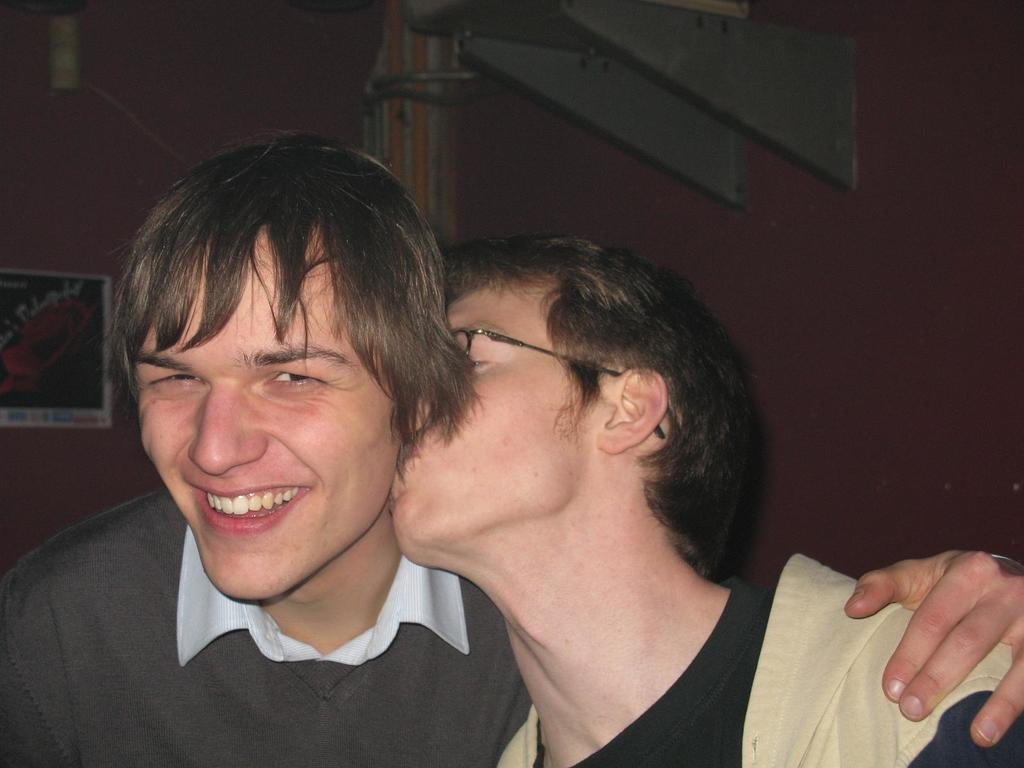How many people are in the image? There are two men in the image. What is one of the men doing in the image? One man is smiling. What action is the other man performing in the image? The other man is kissing the first man on the neck. What can be seen on the wall in the image? There is a post on the wall. What type of thread is being used by the person in the image? There is no person using thread in the image; it features two men interacting with each other. Can you describe the swimming technique of the person in the image? There is no person swimming in the image; it features two men standing and interacting with each other. 